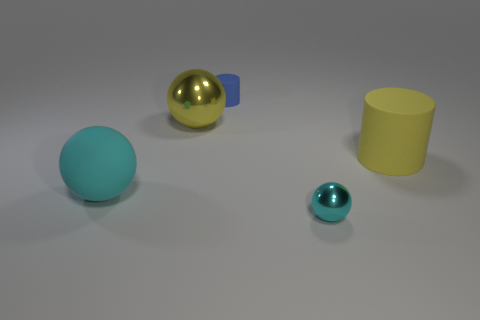Is the color of the large metallic ball the same as the large matte cylinder?
Your answer should be very brief. Yes. There is a big matte object that is the same color as the small sphere; what is its shape?
Your answer should be very brief. Sphere. Is the color of the metallic sphere that is behind the tiny cyan metallic sphere the same as the big matte cylinder?
Your answer should be compact. Yes. Do the small thing behind the small metal object and the large rubber object left of the large yellow metal sphere have the same shape?
Your response must be concise. No. How big is the cyan object that is in front of the matte ball?
Offer a very short reply. Small. What size is the shiny thing that is in front of the cyan thing that is to the left of the blue matte object?
Keep it short and to the point. Small. Is the number of large yellow spheres greater than the number of large blue blocks?
Make the answer very short. Yes. Is the number of cyan objects on the right side of the big metal ball greater than the number of things behind the tiny blue rubber cylinder?
Provide a short and direct response. Yes. What size is the ball that is behind the cyan shiny object and in front of the big cylinder?
Your response must be concise. Large. What number of cyan balls are the same size as the yellow ball?
Offer a terse response. 1. 